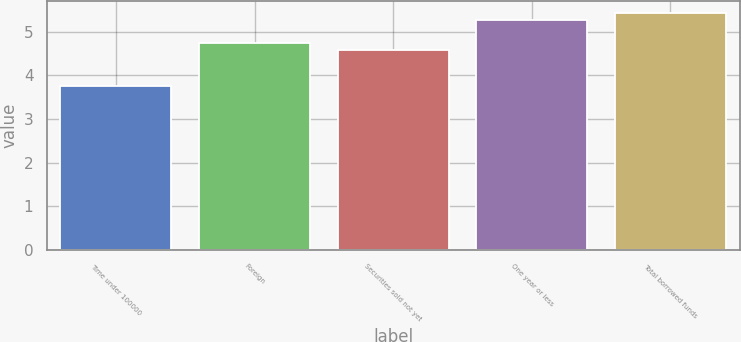Convert chart. <chart><loc_0><loc_0><loc_500><loc_500><bar_chart><fcel>Time under 100000<fcel>Foreign<fcel>Securities sold not yet<fcel>One year or less<fcel>Total borrowed funds<nl><fcel>3.75<fcel>4.73<fcel>4.57<fcel>5.27<fcel>5.43<nl></chart> 